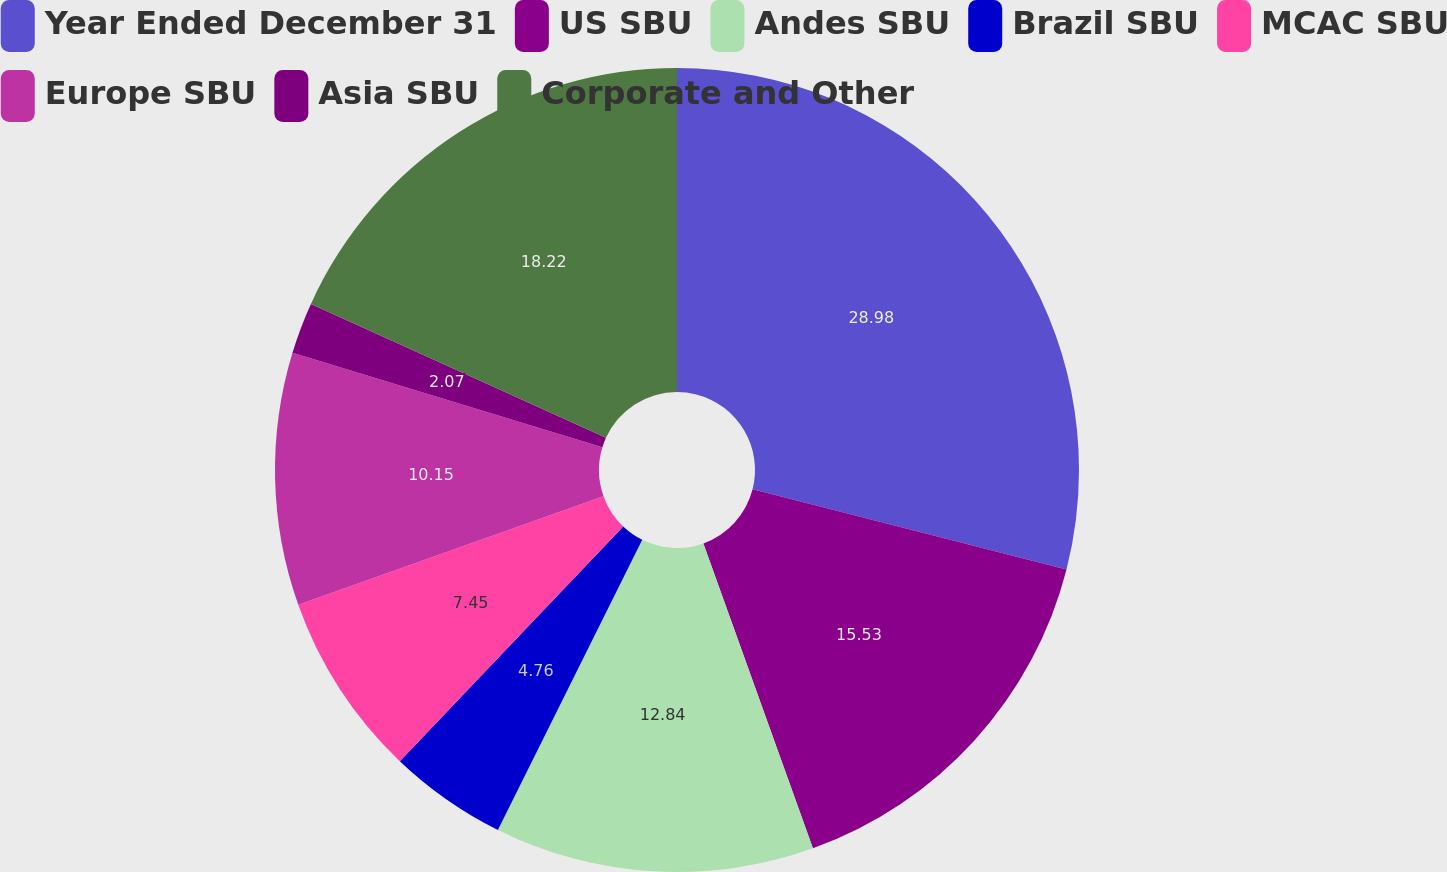<chart> <loc_0><loc_0><loc_500><loc_500><pie_chart><fcel>Year Ended December 31<fcel>US SBU<fcel>Andes SBU<fcel>Brazil SBU<fcel>MCAC SBU<fcel>Europe SBU<fcel>Asia SBU<fcel>Corporate and Other<nl><fcel>28.98%<fcel>15.53%<fcel>12.84%<fcel>4.76%<fcel>7.45%<fcel>10.15%<fcel>2.07%<fcel>18.22%<nl></chart> 